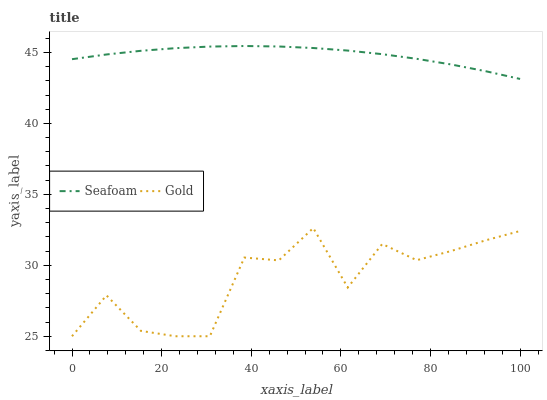Does Gold have the minimum area under the curve?
Answer yes or no. Yes. Does Seafoam have the maximum area under the curve?
Answer yes or no. Yes. Does Gold have the maximum area under the curve?
Answer yes or no. No. Is Seafoam the smoothest?
Answer yes or no. Yes. Is Gold the roughest?
Answer yes or no. Yes. Is Gold the smoothest?
Answer yes or no. No. Does Gold have the lowest value?
Answer yes or no. Yes. Does Seafoam have the highest value?
Answer yes or no. Yes. Does Gold have the highest value?
Answer yes or no. No. Is Gold less than Seafoam?
Answer yes or no. Yes. Is Seafoam greater than Gold?
Answer yes or no. Yes. Does Gold intersect Seafoam?
Answer yes or no. No. 